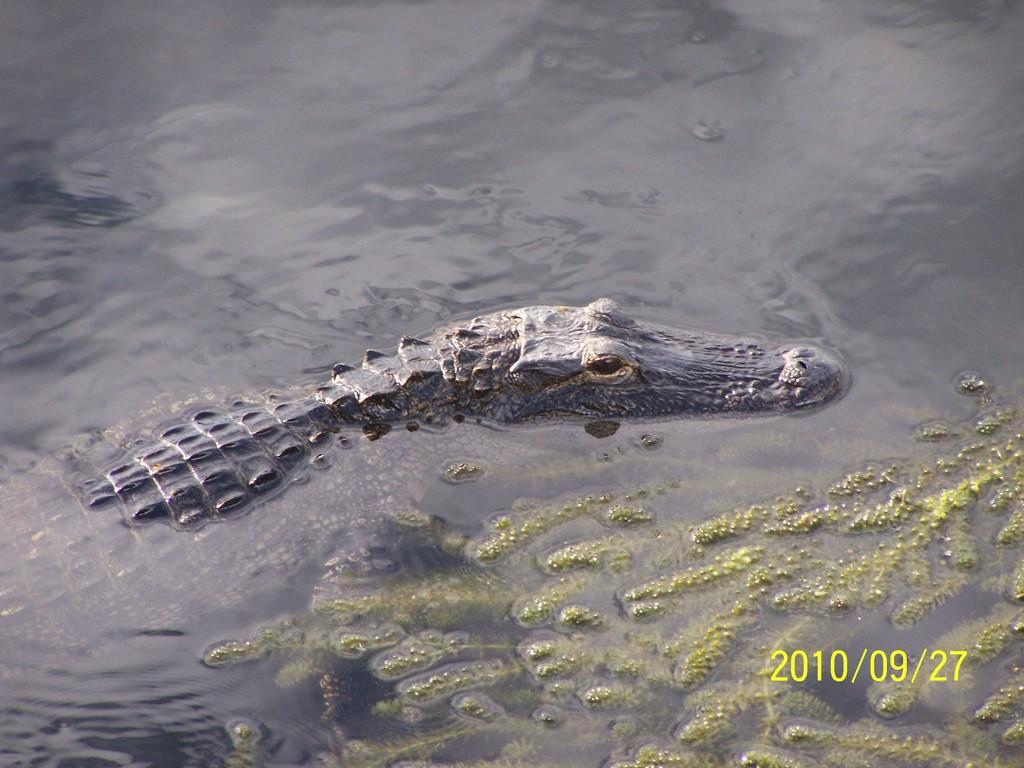What animal can be seen in the water in the image? There is a crocodile in the water in the image. What type of vegetation is present on the right side of the image? There is algae on the right side of the image. What can be found at the bottom of the image? There is some text at the bottom of the image. What time of day is depicted in the image? The time of day cannot be determined from the image, as there are no clues or indicators of the time. 